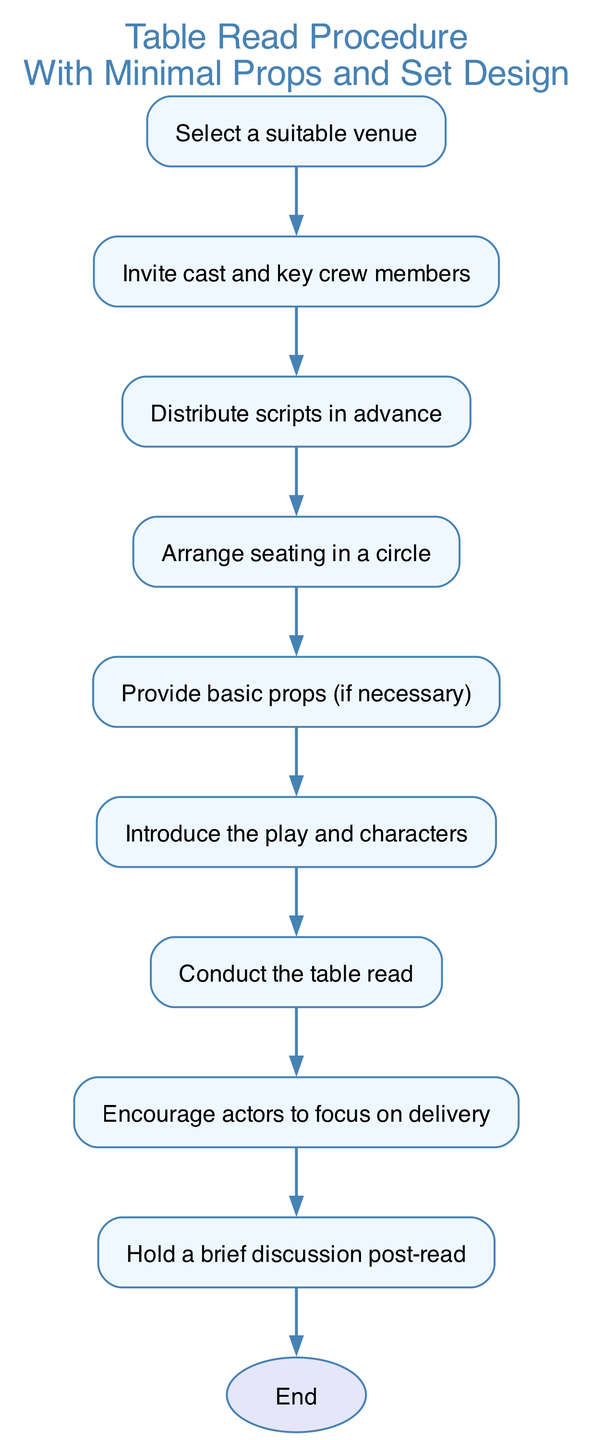What is the first step in the process? The first step in the process is labeled as "Select a suitable venue". It is the top node in the flow chart which indicates the starting point of the table read procedure.
Answer: Select a suitable venue How many main steps are outlined in the diagram? By counting the nodes before the "end", we see that there are 9 main steps that outline the procedure for organizing and running a successful table read.
Answer: 9 What is provided in step 5? In step 5, it is mentioned to "Provide basic props (if necessary)", indicating a suggestion for minimal needs in the arrangement.
Answer: Provide basic props (if necessary) Which step follows the "Conduct the table read"? After "Conduct the table read", according to the flow, the next step is "Encourage actors to focus on delivery". This indicates a continuous effort in guiding the cast after the reading.
Answer: Encourage actors to focus on delivery What is the relationship between steps 3 and 4? The relationship between steps 3 and 4 shows that after distributing scripts in advance, the next action is to arrange seating in a circle. This indicates a sequential dependency on preparing for the table read.
Answer: Distributing scripts leads to arranging seating in a circle What is the purpose of introducing step 6? Step 6, labeled as "Introduce the play and characters", serves to familiarize the cast with the context of the play before they participate in the reading, thereby enhancing their understanding for better performance.
Answer: Familiarize the cast with context Describe the final activity in the procedure. The final activity is to "Hold a brief discussion post-read", indicating that concluding the read involves gathering feedback and reflecting on the reading experience collaboratively.
Answer: Hold a brief discussion post-read What kind of seating arrangement is recommended? The diagram suggests an "Arrange seating in a circle" configuration, which promotes inclusivity and allows all participants to engage visually and auditorily with one another.
Answer: Arrange seating in a circle Identify the last node before reaching the end of the flowchart. The last node before reaching the end is labeled "Hold a brief discussion post-read". This indicates that engaging in discussion is the concluding part of the set procedure.
Answer: Hold a brief discussion post-read 